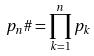Convert formula to latex. <formula><loc_0><loc_0><loc_500><loc_500>p _ { n } \# = \prod _ { k = 1 } ^ { n } p _ { k }</formula> 